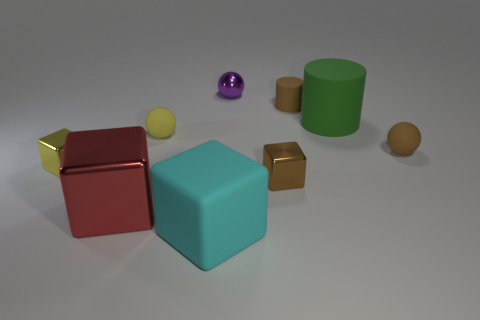How many other things are there of the same size as the cyan matte block?
Provide a short and direct response. 2. Do the small brown rubber thing that is in front of the green thing and the big green matte thing have the same shape?
Ensure brevity in your answer.  No. There is a tiny matte object that is the same shape as the big green matte thing; what color is it?
Offer a very short reply. Brown. Is there any other thing that has the same shape as the yellow metallic object?
Offer a very short reply. Yes. Are there the same number of tiny metal balls that are on the left side of the yellow metal thing and large green matte cylinders?
Your answer should be compact. No. How many big objects are both left of the yellow ball and right of the small brown cube?
Give a very brief answer. 0. What is the size of the yellow thing that is the same shape as the purple object?
Offer a very short reply. Small. How many small purple things have the same material as the tiny cylinder?
Make the answer very short. 0. Are there fewer brown things to the left of the yellow metal cube than green cylinders?
Offer a very short reply. Yes. How many small yellow rubber cylinders are there?
Offer a terse response. 0. 